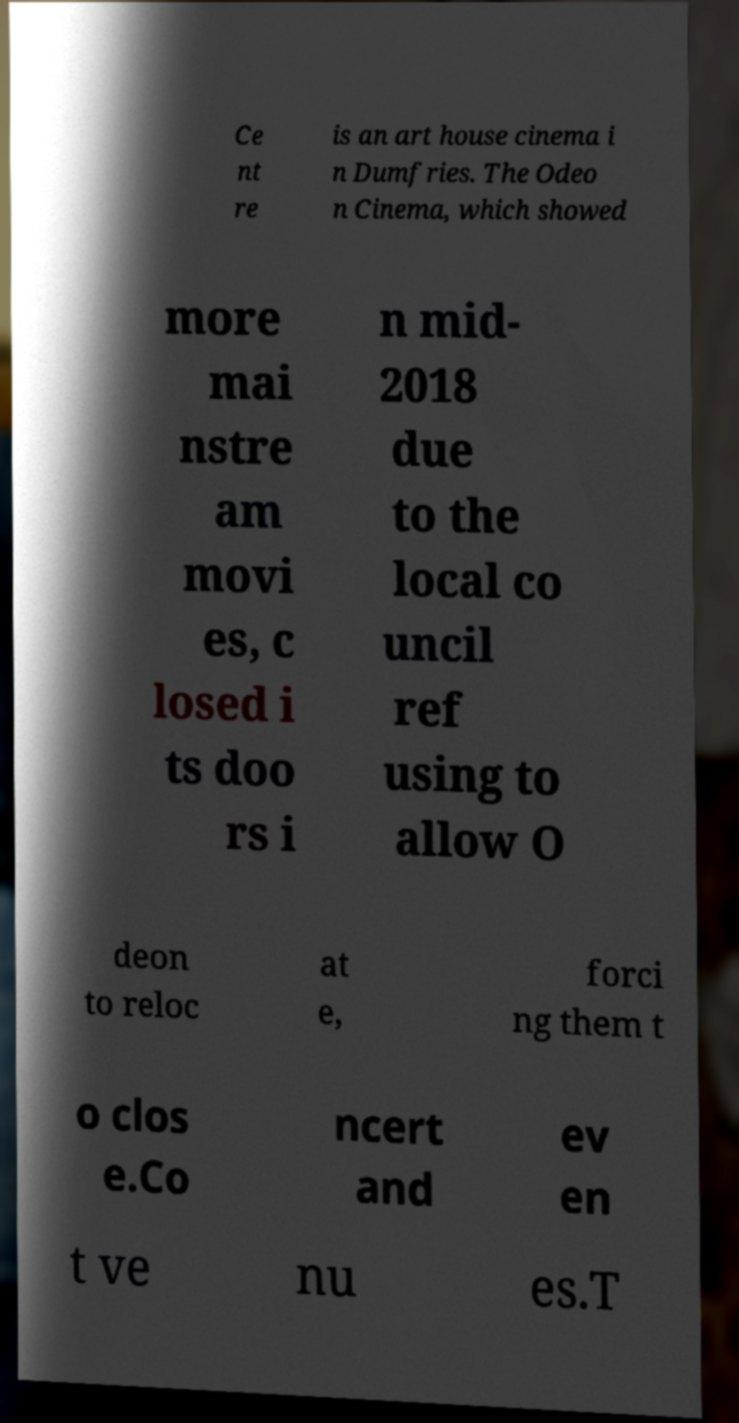Can you accurately transcribe the text from the provided image for me? Ce nt re is an art house cinema i n Dumfries. The Odeo n Cinema, which showed more mai nstre am movi es, c losed i ts doo rs i n mid- 2018 due to the local co uncil ref using to allow O deon to reloc at e, forci ng them t o clos e.Co ncert and ev en t ve nu es.T 